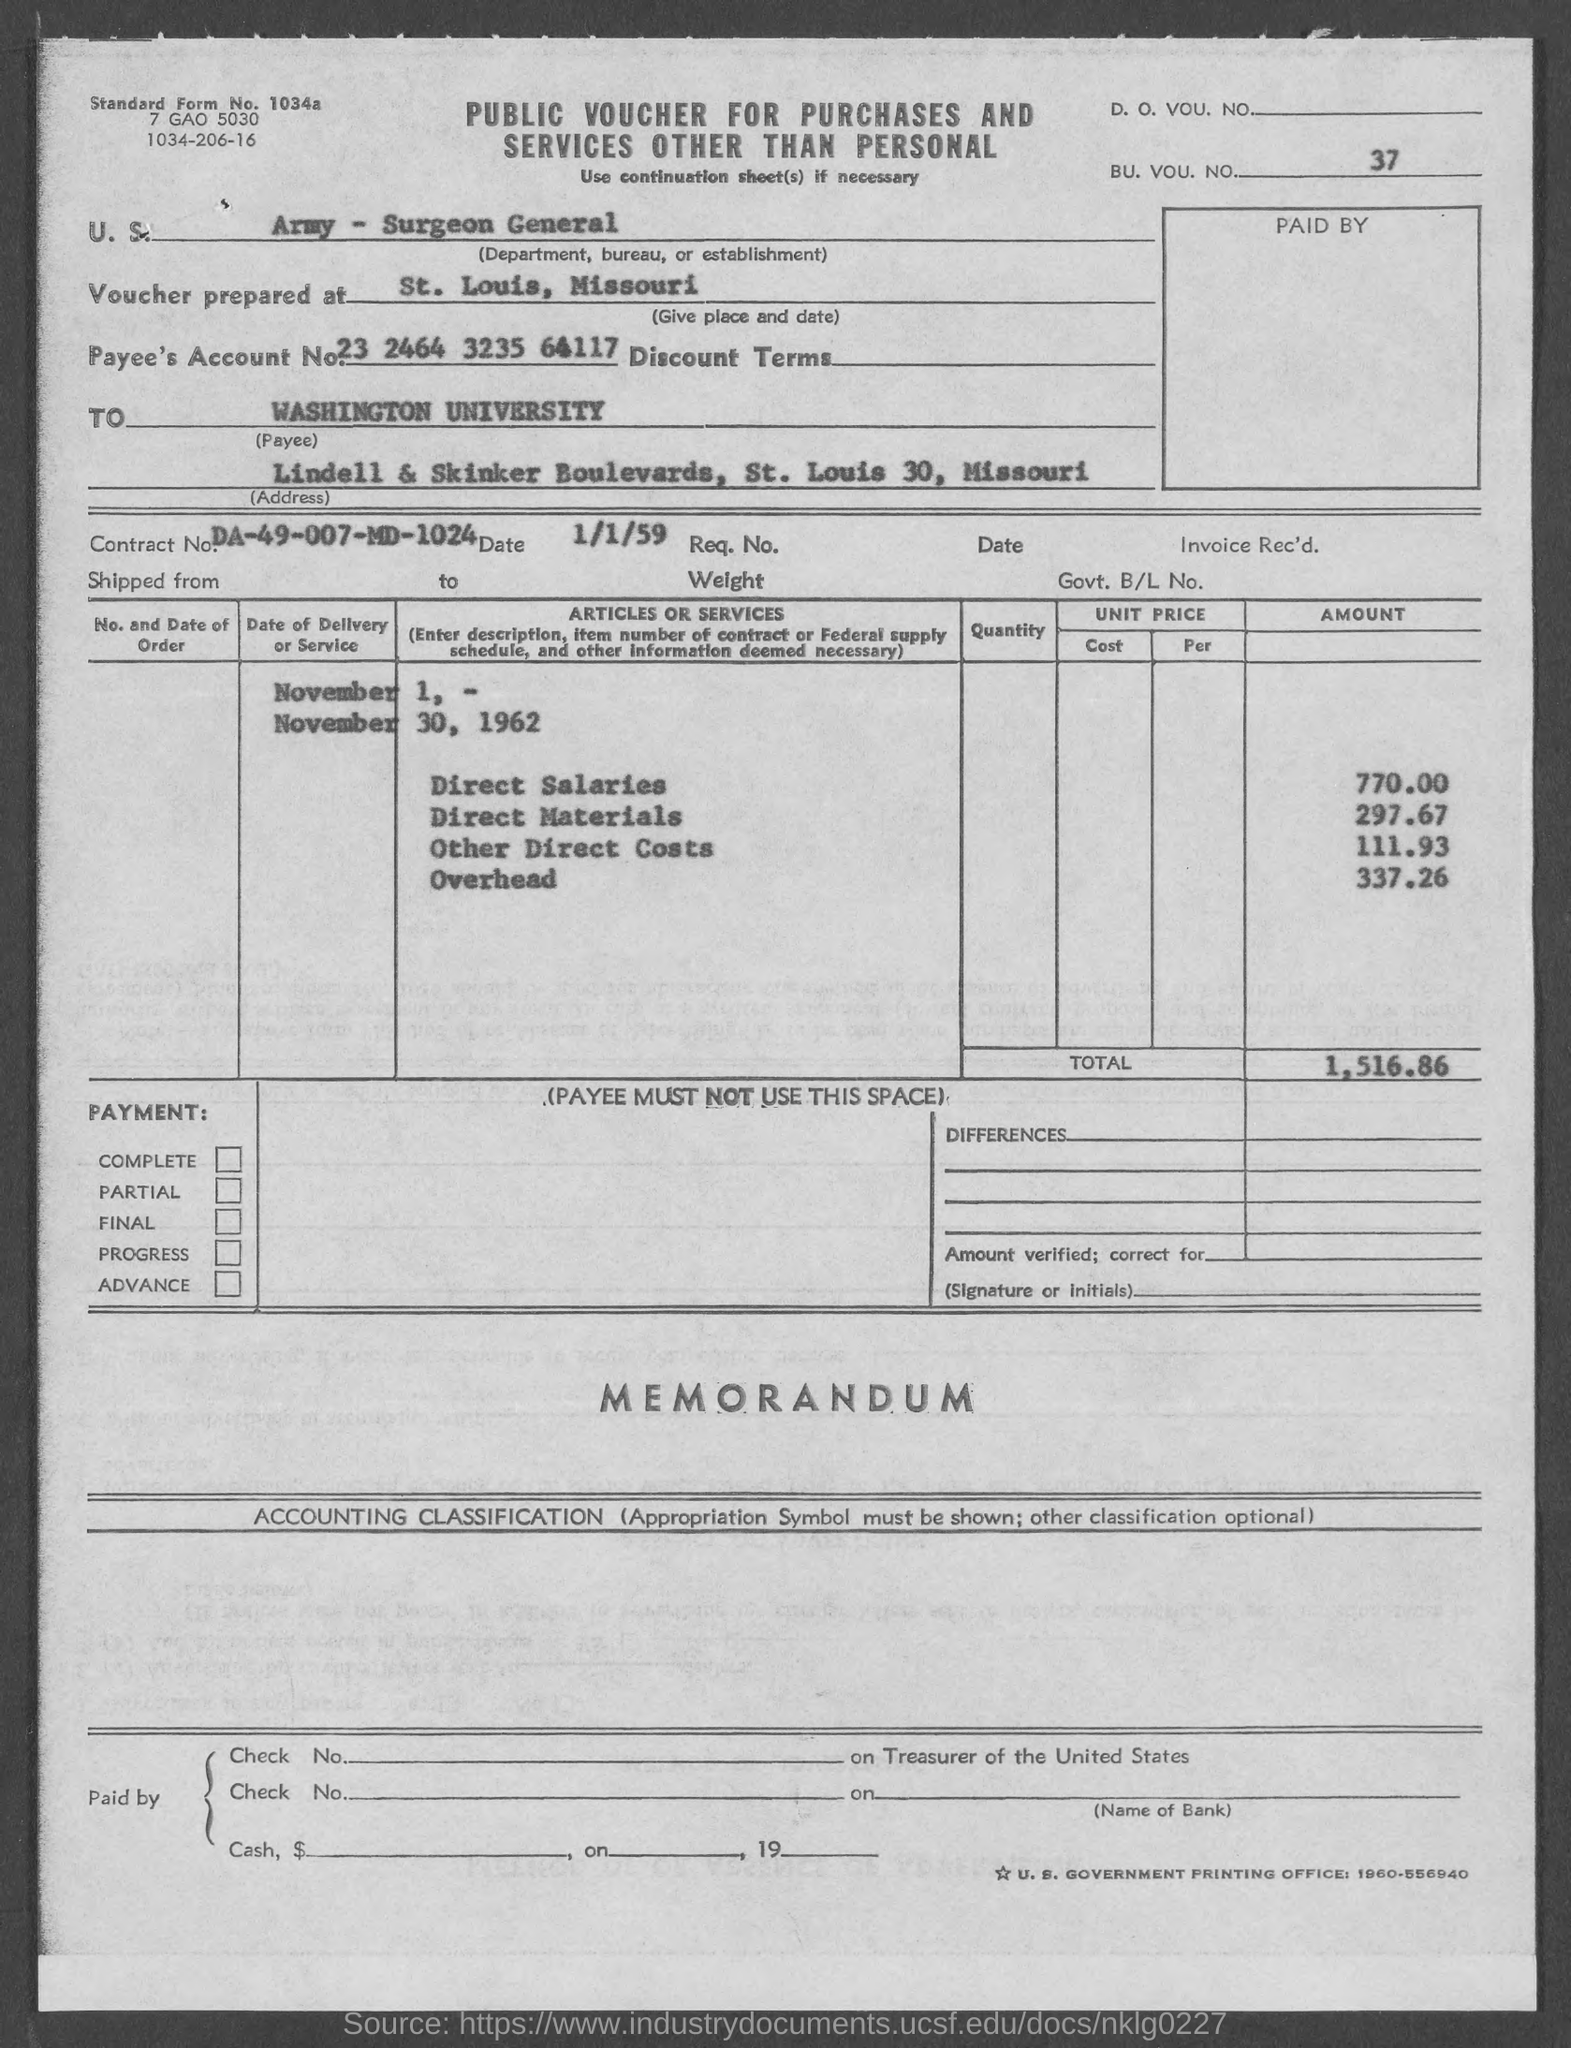What is the bu. vou. no. mentioned in the given page ?
Ensure brevity in your answer.  37. At what place voucher is prepared ?
Offer a very short reply. St. louis , missouri. What is the payee's account no. mentioned in the given form ?
Ensure brevity in your answer.  23 2464 3235 64117. What is the contract no. mentioned in the given form ?
Offer a terse response. DA-49-007-MD-1024. What is the date mentioned in the given page ?
Provide a succinct answer. 1/1/59. What is the amount of direct salaries as mentioned in the given form ?
Offer a terse response. 770.00. What is the amount of direct materials mentioned in the given page ?
Your answer should be very brief. 297.67. What is the amount of other direct cots mentioned in the given page ?
Ensure brevity in your answer.  111.93. What is the amount of overhead as mentioned in the given form ?
Your answer should be compact. 337.26. What is the total amount mentioned in the given form ?
Offer a terse response. 1,516.86. 